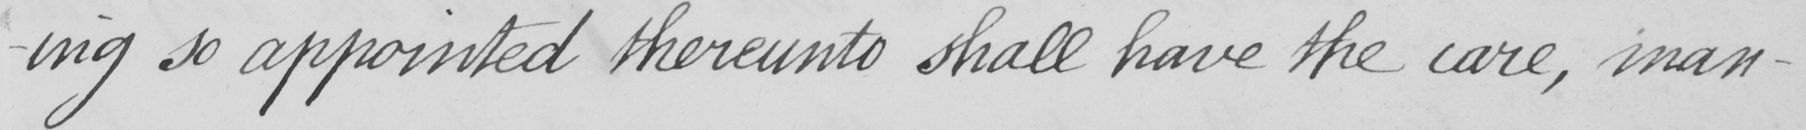What does this handwritten line say? so appointed thereunto shall have the care , man- 